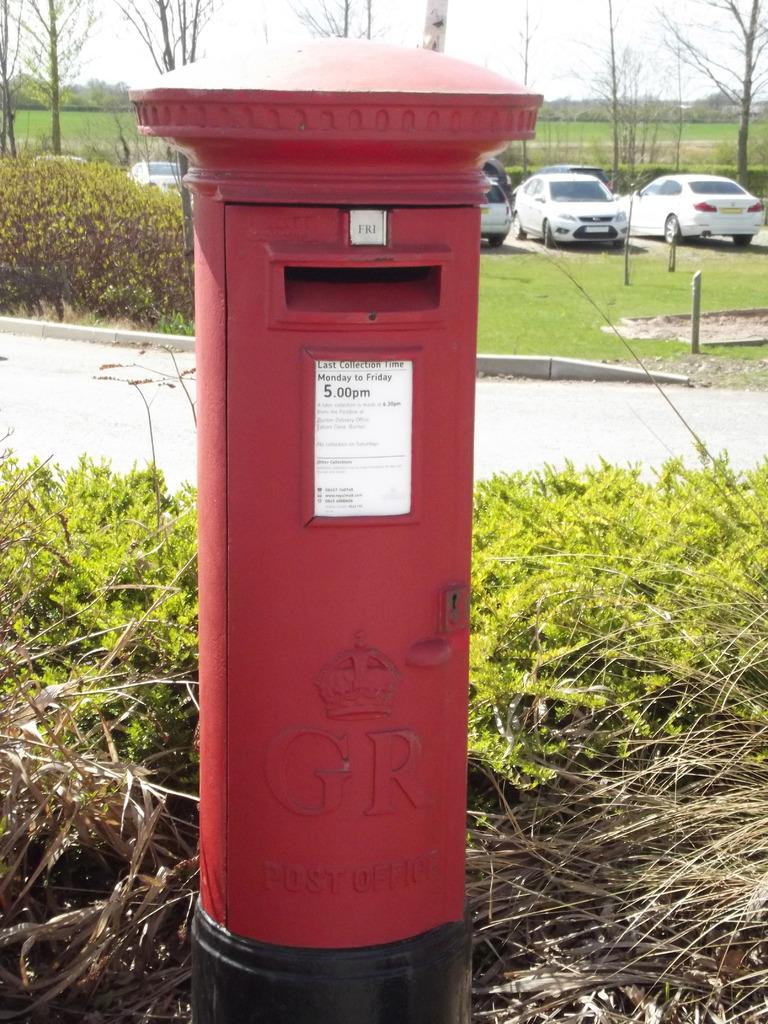What object is present in the image for sending mail? There is a post box in the image for sending mail. What type of vegetation can be seen in the image? There are plants and trees in the image. What is the ground surface like in the image? There is grass and a pathway in the image. What can be seen in the background of the image? In the background, there are cars, trees, and the sky. How does the glass help the plants grow in the image? There is no glass present in the image, so it cannot help the plants grow. 